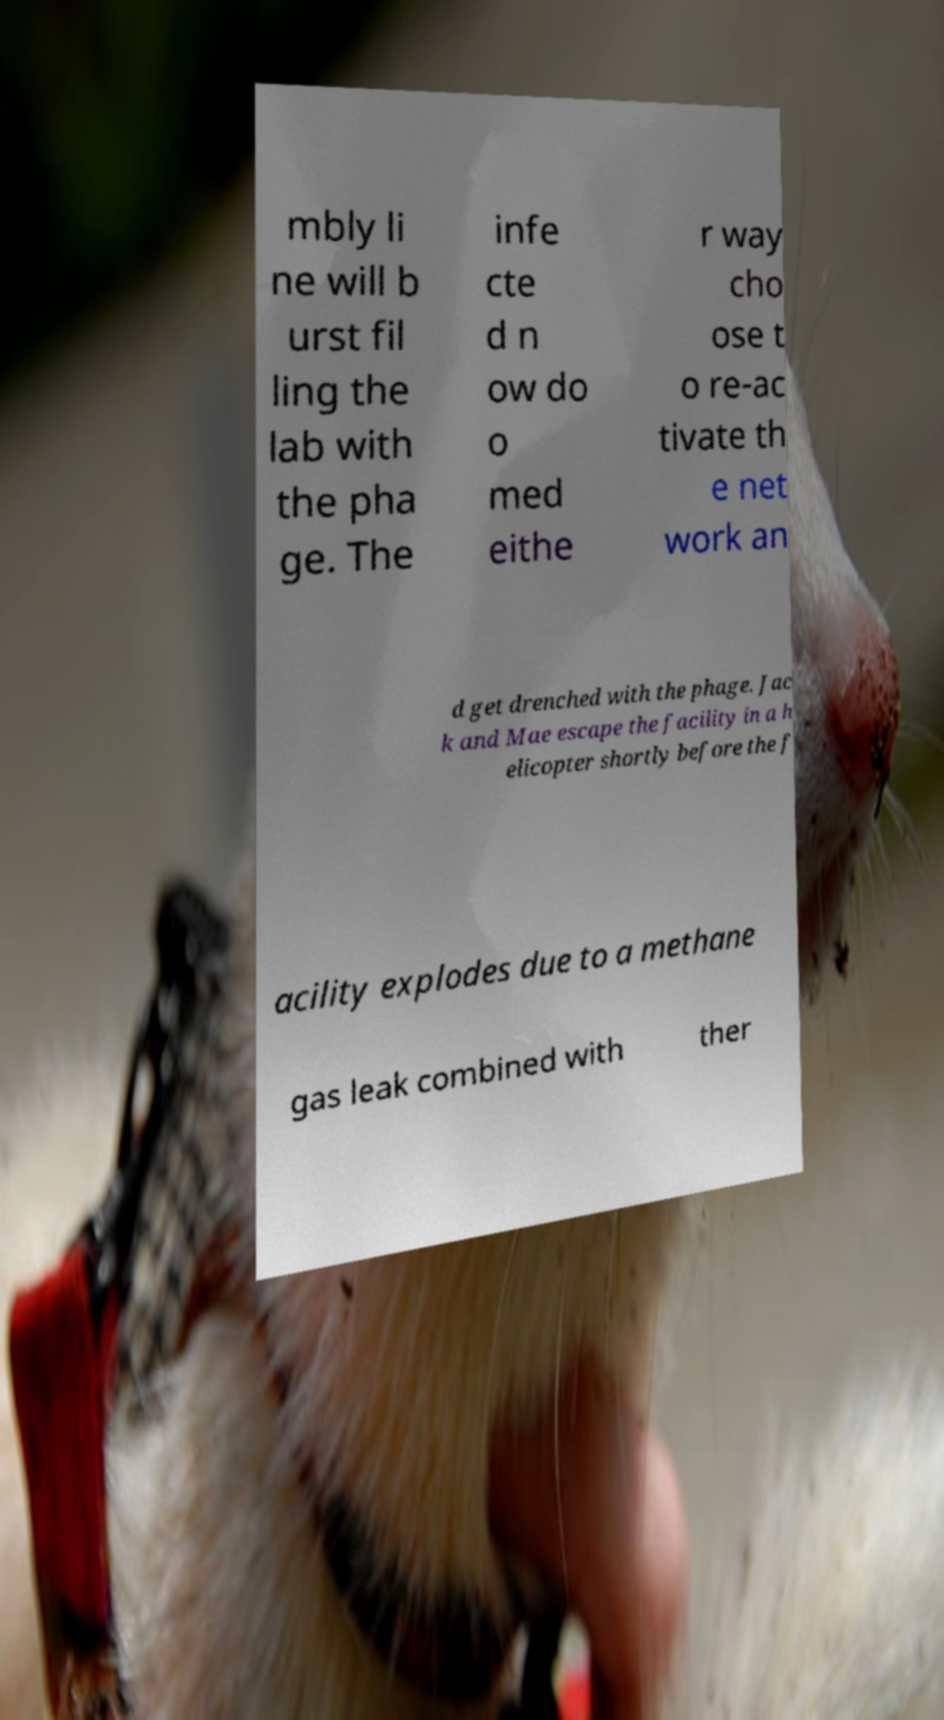Please read and relay the text visible in this image. What does it say? mbly li ne will b urst fil ling the lab with the pha ge. The infe cte d n ow do o med eithe r way cho ose t o re-ac tivate th e net work an d get drenched with the phage. Jac k and Mae escape the facility in a h elicopter shortly before the f acility explodes due to a methane gas leak combined with ther 